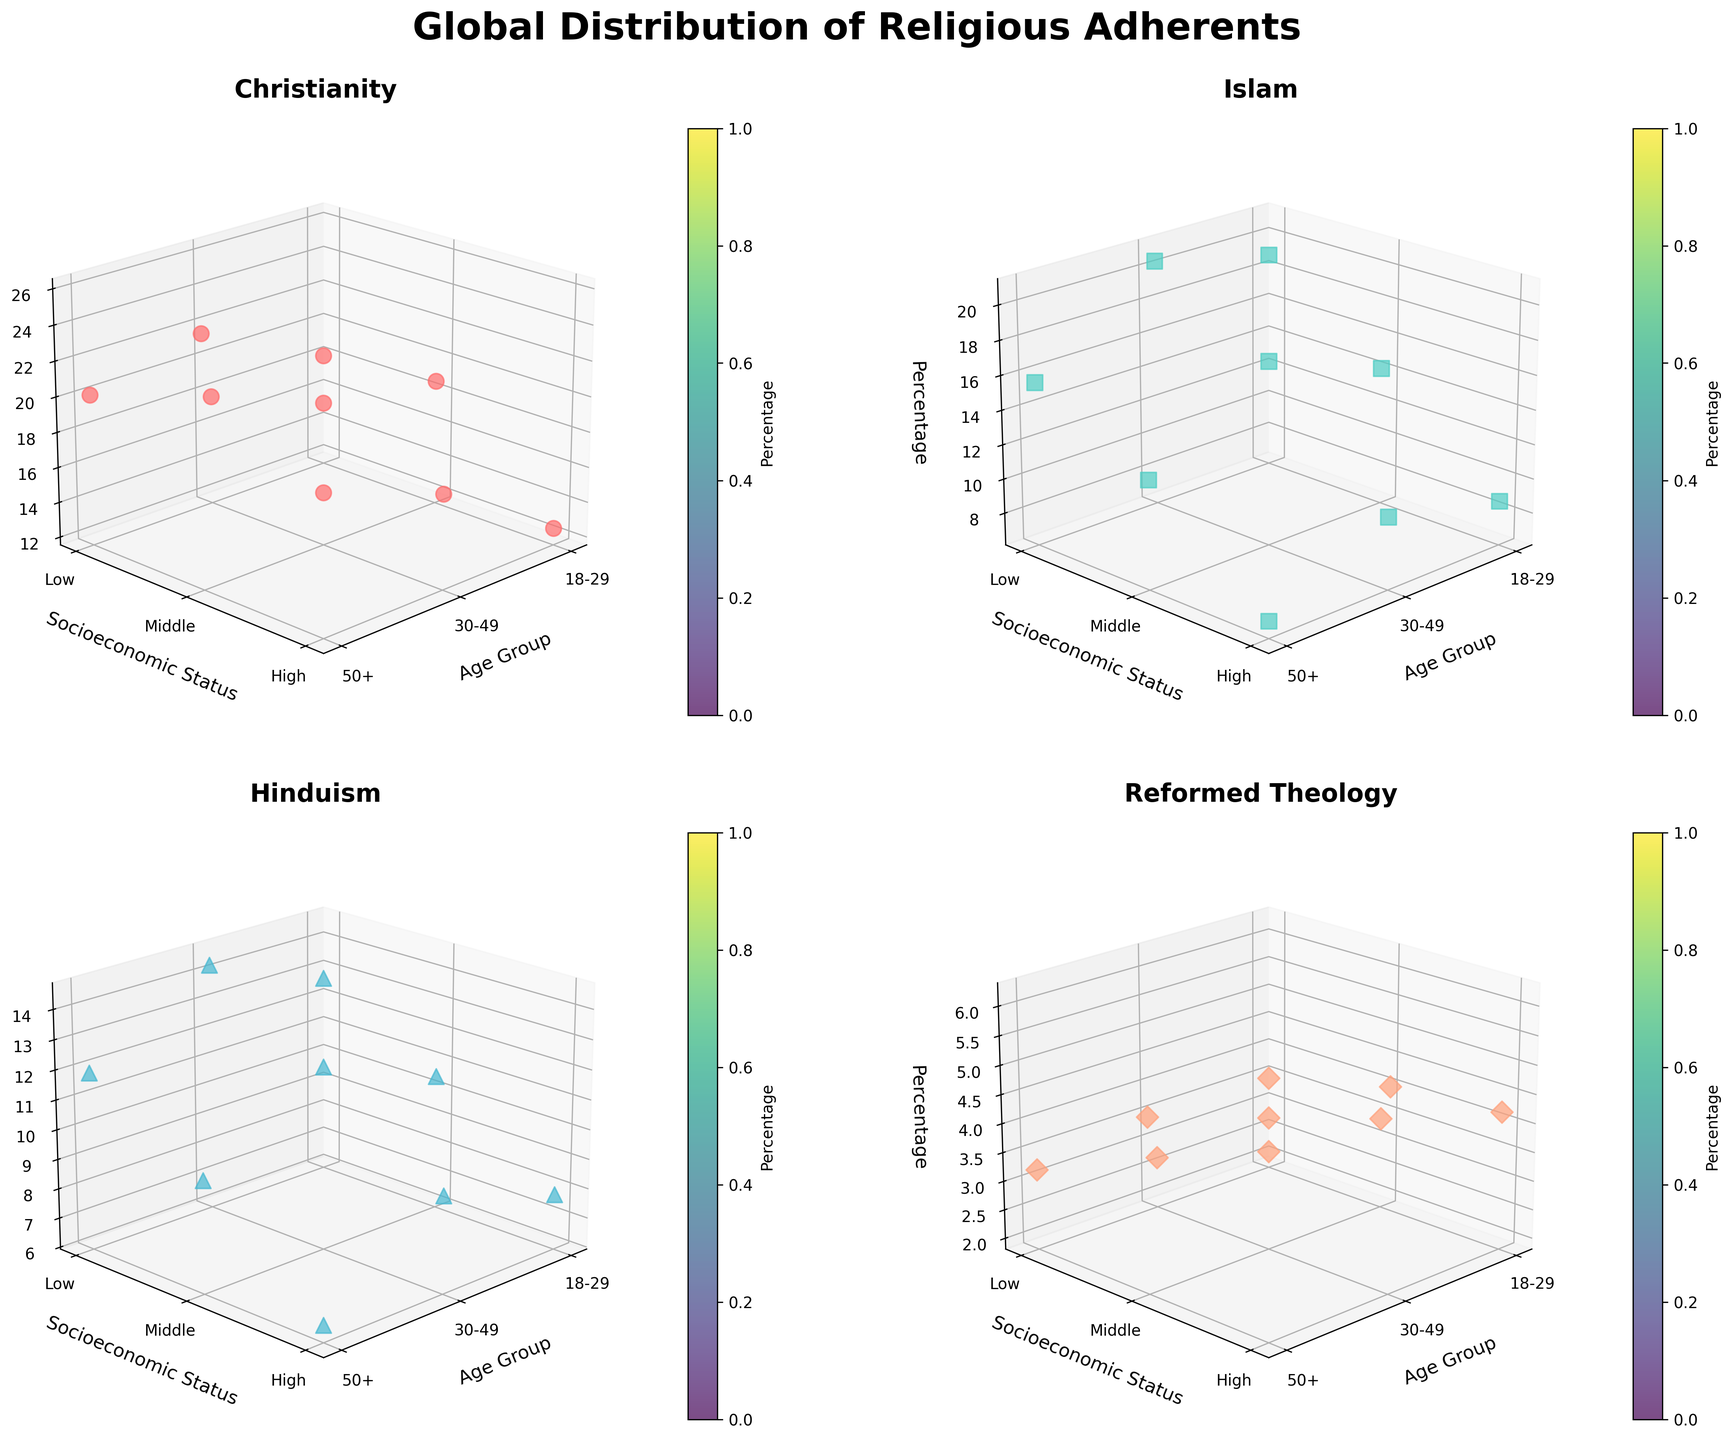What's the title of the figure? The title is located at the top center of the figure, it reads "Global Distribution of Religious Adherents."
Answer: Global Distribution of Religious Adherents Which religious tradition has the highest percentage among those aged 30-49 with middle income? Look at the subplot titled with each religious tradition, and find the one with the highest value on the percentage axis for middle income within the 30-49 age group.
Answer: Christianity How does the percentage of Reformed Theology adherents aged 18-29 with high income compare to those aged 30-49 with high income? Observe the Reformed Theology subplot and compare the z-values for the given age groups under high income. The percentage for those aged 18-29 is 4.2%, and for those aged 30-49, it is 5.3%.
Answer: 18-29 is lower What is the combined percentage of Hindu adherents aged 50+ within the low and middle-income groups? Check the Hinduism subplot. Add the percentages for the specified age group and income levels: 11.9% (Low) + 9.7% (Middle).
Answer: 21.6% Which socioeconomic status group has the lowest adherence to Islam among those aged 50+? In the Islam subplot, find the group with the smallest value for those aged 50+ on the percentage axis. The values are 15.6% (Low), 12.4% (Middle), and 7.1% (High).
Answer: High Income Among all the traditions, which one has the most substantial difference in adherence percentage between low and high-income groups for those aged 30-49? Check each subplot, and calculate the difference for the specified age and income groups. Christianity: 17.8%-16.9%=0.9, Islam: 20.5%-10.3%=10.2, Hinduism: 14.3%-9.2%=5.1, Reformed Theology: 2.7%-5.3%=2.6.
Answer: Islam Which age group sees the highest percentage of Christian adherents across all income levels? Examine the Christianity subplot for the highest peak across all age groups. Compare the peaks in different age groups: 18-29 (18.7%), 30-49 (22.3%), 50+ (25.6%).
Answer: 50+ What is the percentage range of low-income adherents of Hinduism across all age groups? Look at the Hinduism subplot and determine the lowest and highest values on the z-axis for low-income levels: 12.7% (18-29), 14.3% (30-49), 11.9% (50+). The range is from 11.9% to 14.3%.
Answer: 11.9% to 14.3% Which faith tradition has the most evenly distributed percentages across all socioeconomic statuses for the 18-29 age group? Review the subplots and compare the spread of percentages for each faith tradition in the specified age group. Reformed Theology shows percentages close to each other: 2.1% (Low), 3.4% (Middle), 4.2% (High).
Answer: Reformed Theology 